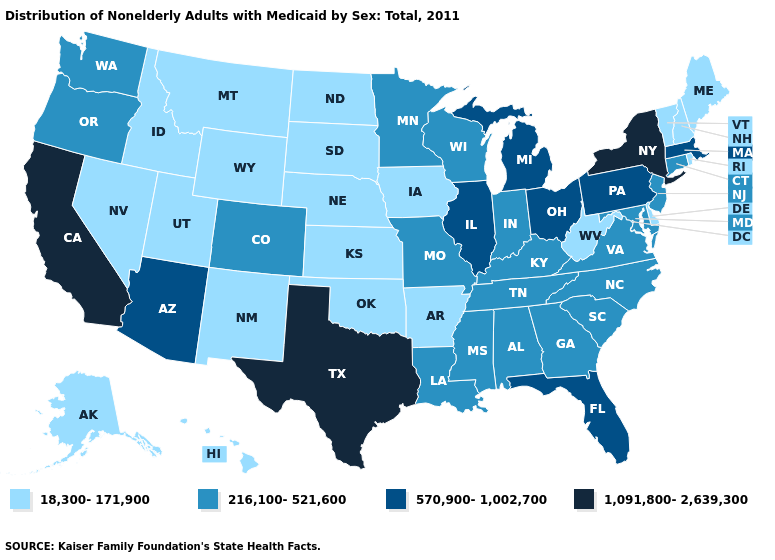Does Maine have the lowest value in the USA?
Quick response, please. Yes. Name the states that have a value in the range 216,100-521,600?
Give a very brief answer. Alabama, Colorado, Connecticut, Georgia, Indiana, Kentucky, Louisiana, Maryland, Minnesota, Mississippi, Missouri, New Jersey, North Carolina, Oregon, South Carolina, Tennessee, Virginia, Washington, Wisconsin. What is the value of Arizona?
Be succinct. 570,900-1,002,700. Name the states that have a value in the range 1,091,800-2,639,300?
Be succinct. California, New York, Texas. What is the lowest value in states that border Delaware?
Keep it brief. 216,100-521,600. Name the states that have a value in the range 570,900-1,002,700?
Concise answer only. Arizona, Florida, Illinois, Massachusetts, Michigan, Ohio, Pennsylvania. Name the states that have a value in the range 18,300-171,900?
Concise answer only. Alaska, Arkansas, Delaware, Hawaii, Idaho, Iowa, Kansas, Maine, Montana, Nebraska, Nevada, New Hampshire, New Mexico, North Dakota, Oklahoma, Rhode Island, South Dakota, Utah, Vermont, West Virginia, Wyoming. What is the value of Nebraska?
Short answer required. 18,300-171,900. What is the value of New Hampshire?
Give a very brief answer. 18,300-171,900. Name the states that have a value in the range 570,900-1,002,700?
Keep it brief. Arizona, Florida, Illinois, Massachusetts, Michigan, Ohio, Pennsylvania. What is the value of California?
Quick response, please. 1,091,800-2,639,300. What is the value of New Hampshire?
Quick response, please. 18,300-171,900. What is the value of Nebraska?
Keep it brief. 18,300-171,900. Does Kentucky have the same value as Michigan?
Give a very brief answer. No. What is the lowest value in states that border Massachusetts?
Keep it brief. 18,300-171,900. 